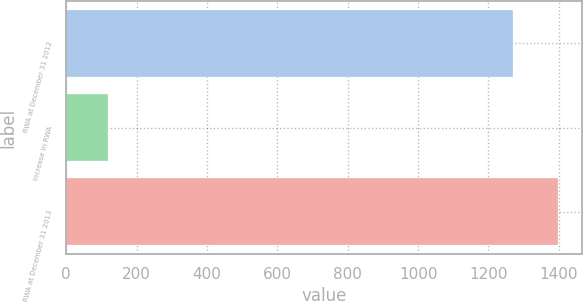Convert chart to OTSL. <chart><loc_0><loc_0><loc_500><loc_500><bar_chart><fcel>RWA at December 31 2012<fcel>Increase in RWA<fcel>RWA at December 31 2013<nl><fcel>1270<fcel>118<fcel>1397<nl></chart> 